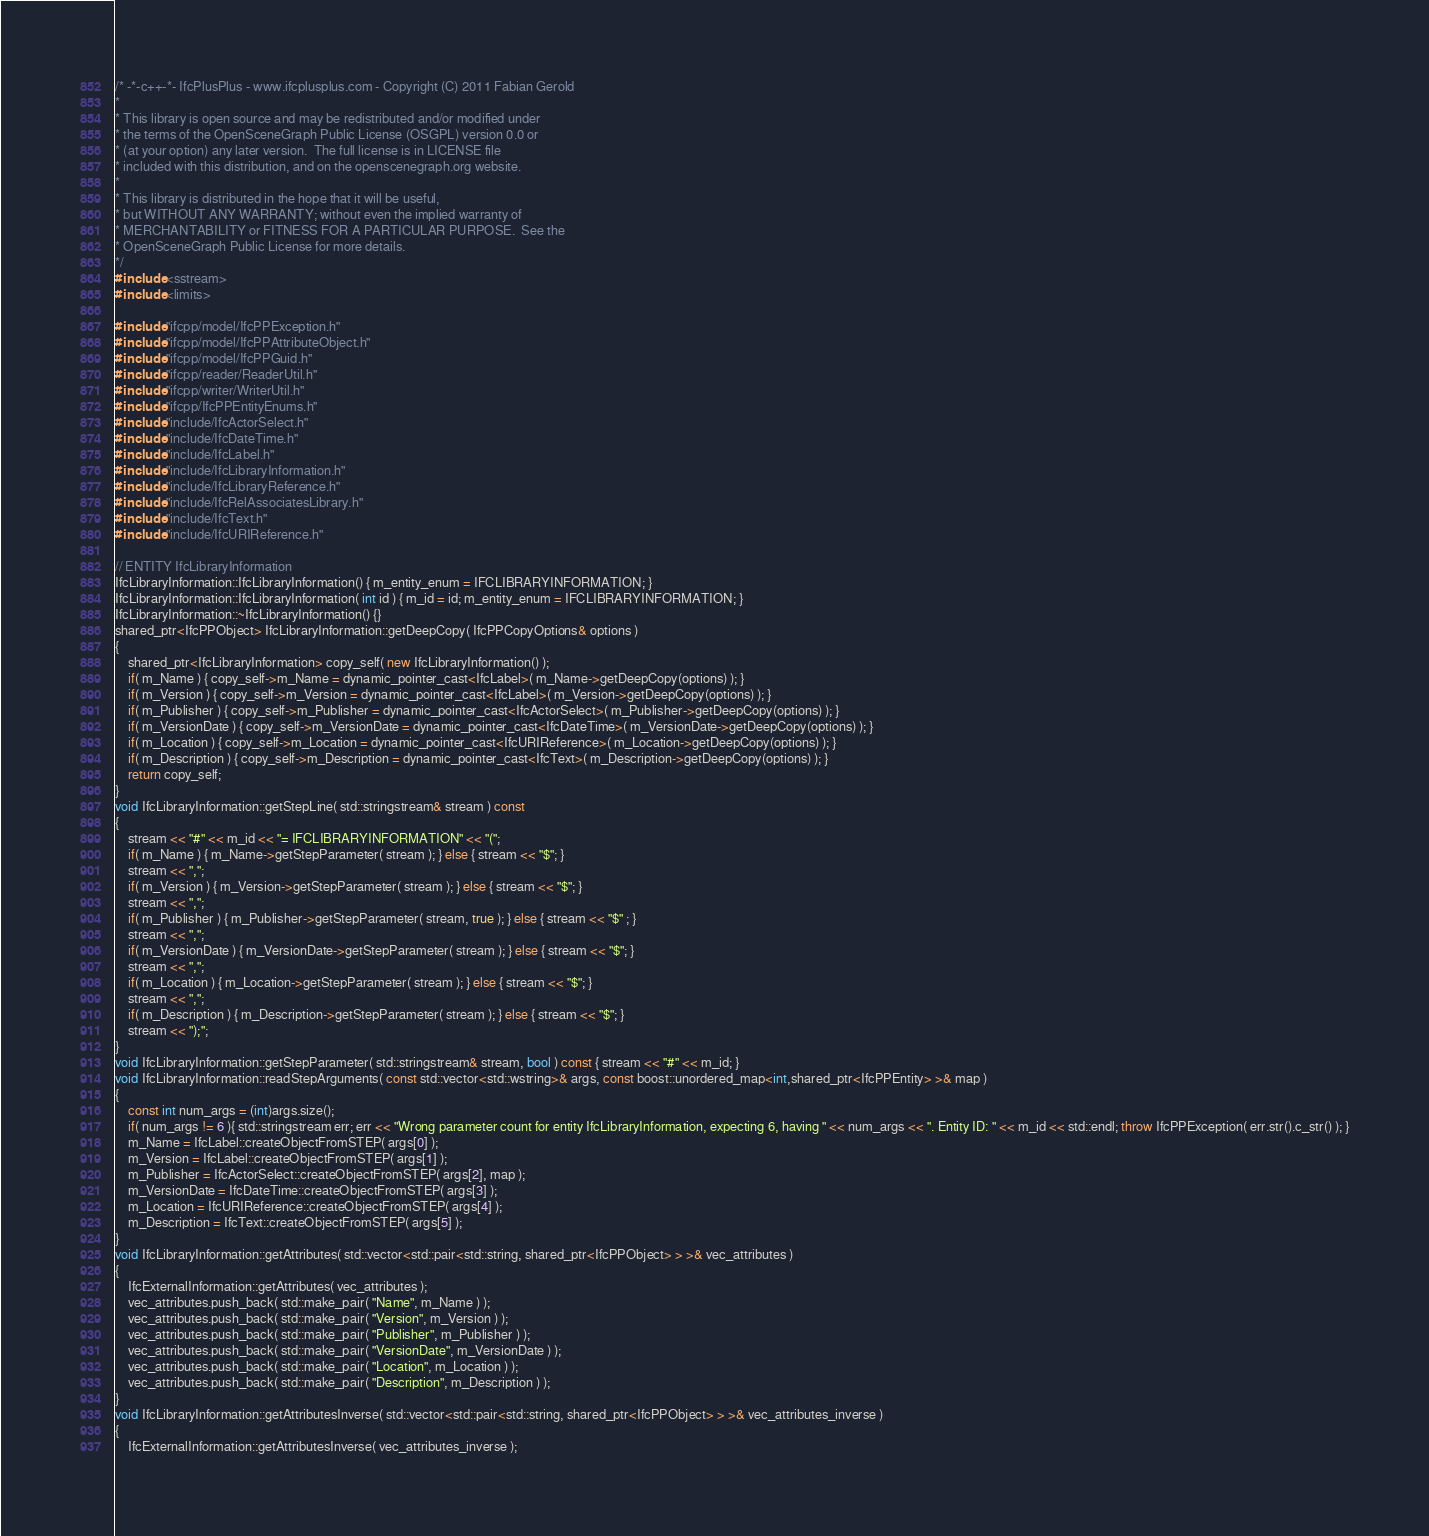<code> <loc_0><loc_0><loc_500><loc_500><_C++_>/* -*-c++-*- IfcPlusPlus - www.ifcplusplus.com - Copyright (C) 2011 Fabian Gerold
*
* This library is open source and may be redistributed and/or modified under  
* the terms of the OpenSceneGraph Public License (OSGPL) version 0.0 or 
* (at your option) any later version.  The full license is in LICENSE file
* included with this distribution, and on the openscenegraph.org website.
* 
* This library is distributed in the hope that it will be useful,
* but WITHOUT ANY WARRANTY; without even the implied warranty of
* MERCHANTABILITY or FITNESS FOR A PARTICULAR PURPOSE.  See the 
* OpenSceneGraph Public License for more details.
*/
#include <sstream>
#include <limits>

#include "ifcpp/model/IfcPPException.h"
#include "ifcpp/model/IfcPPAttributeObject.h"
#include "ifcpp/model/IfcPPGuid.h"
#include "ifcpp/reader/ReaderUtil.h"
#include "ifcpp/writer/WriterUtil.h"
#include "ifcpp/IfcPPEntityEnums.h"
#include "include/IfcActorSelect.h"
#include "include/IfcDateTime.h"
#include "include/IfcLabel.h"
#include "include/IfcLibraryInformation.h"
#include "include/IfcLibraryReference.h"
#include "include/IfcRelAssociatesLibrary.h"
#include "include/IfcText.h"
#include "include/IfcURIReference.h"

// ENTITY IfcLibraryInformation 
IfcLibraryInformation::IfcLibraryInformation() { m_entity_enum = IFCLIBRARYINFORMATION; }
IfcLibraryInformation::IfcLibraryInformation( int id ) { m_id = id; m_entity_enum = IFCLIBRARYINFORMATION; }
IfcLibraryInformation::~IfcLibraryInformation() {}
shared_ptr<IfcPPObject> IfcLibraryInformation::getDeepCopy( IfcPPCopyOptions& options )
{
	shared_ptr<IfcLibraryInformation> copy_self( new IfcLibraryInformation() );
	if( m_Name ) { copy_self->m_Name = dynamic_pointer_cast<IfcLabel>( m_Name->getDeepCopy(options) ); }
	if( m_Version ) { copy_self->m_Version = dynamic_pointer_cast<IfcLabel>( m_Version->getDeepCopy(options) ); }
	if( m_Publisher ) { copy_self->m_Publisher = dynamic_pointer_cast<IfcActorSelect>( m_Publisher->getDeepCopy(options) ); }
	if( m_VersionDate ) { copy_self->m_VersionDate = dynamic_pointer_cast<IfcDateTime>( m_VersionDate->getDeepCopy(options) ); }
	if( m_Location ) { copy_self->m_Location = dynamic_pointer_cast<IfcURIReference>( m_Location->getDeepCopy(options) ); }
	if( m_Description ) { copy_self->m_Description = dynamic_pointer_cast<IfcText>( m_Description->getDeepCopy(options) ); }
	return copy_self;
}
void IfcLibraryInformation::getStepLine( std::stringstream& stream ) const
{
	stream << "#" << m_id << "= IFCLIBRARYINFORMATION" << "(";
	if( m_Name ) { m_Name->getStepParameter( stream ); } else { stream << "$"; }
	stream << ",";
	if( m_Version ) { m_Version->getStepParameter( stream ); } else { stream << "$"; }
	stream << ",";
	if( m_Publisher ) { m_Publisher->getStepParameter( stream, true ); } else { stream << "$" ; }
	stream << ",";
	if( m_VersionDate ) { m_VersionDate->getStepParameter( stream ); } else { stream << "$"; }
	stream << ",";
	if( m_Location ) { m_Location->getStepParameter( stream ); } else { stream << "$"; }
	stream << ",";
	if( m_Description ) { m_Description->getStepParameter( stream ); } else { stream << "$"; }
	stream << ");";
}
void IfcLibraryInformation::getStepParameter( std::stringstream& stream, bool ) const { stream << "#" << m_id; }
void IfcLibraryInformation::readStepArguments( const std::vector<std::wstring>& args, const boost::unordered_map<int,shared_ptr<IfcPPEntity> >& map )
{
	const int num_args = (int)args.size();
	if( num_args != 6 ){ std::stringstream err; err << "Wrong parameter count for entity IfcLibraryInformation, expecting 6, having " << num_args << ". Entity ID: " << m_id << std::endl; throw IfcPPException( err.str().c_str() ); }
	m_Name = IfcLabel::createObjectFromSTEP( args[0] );
	m_Version = IfcLabel::createObjectFromSTEP( args[1] );
	m_Publisher = IfcActorSelect::createObjectFromSTEP( args[2], map );
	m_VersionDate = IfcDateTime::createObjectFromSTEP( args[3] );
	m_Location = IfcURIReference::createObjectFromSTEP( args[4] );
	m_Description = IfcText::createObjectFromSTEP( args[5] );
}
void IfcLibraryInformation::getAttributes( std::vector<std::pair<std::string, shared_ptr<IfcPPObject> > >& vec_attributes )
{
	IfcExternalInformation::getAttributes( vec_attributes );
	vec_attributes.push_back( std::make_pair( "Name", m_Name ) );
	vec_attributes.push_back( std::make_pair( "Version", m_Version ) );
	vec_attributes.push_back( std::make_pair( "Publisher", m_Publisher ) );
	vec_attributes.push_back( std::make_pair( "VersionDate", m_VersionDate ) );
	vec_attributes.push_back( std::make_pair( "Location", m_Location ) );
	vec_attributes.push_back( std::make_pair( "Description", m_Description ) );
}
void IfcLibraryInformation::getAttributesInverse( std::vector<std::pair<std::string, shared_ptr<IfcPPObject> > >& vec_attributes_inverse )
{
	IfcExternalInformation::getAttributesInverse( vec_attributes_inverse );</code> 